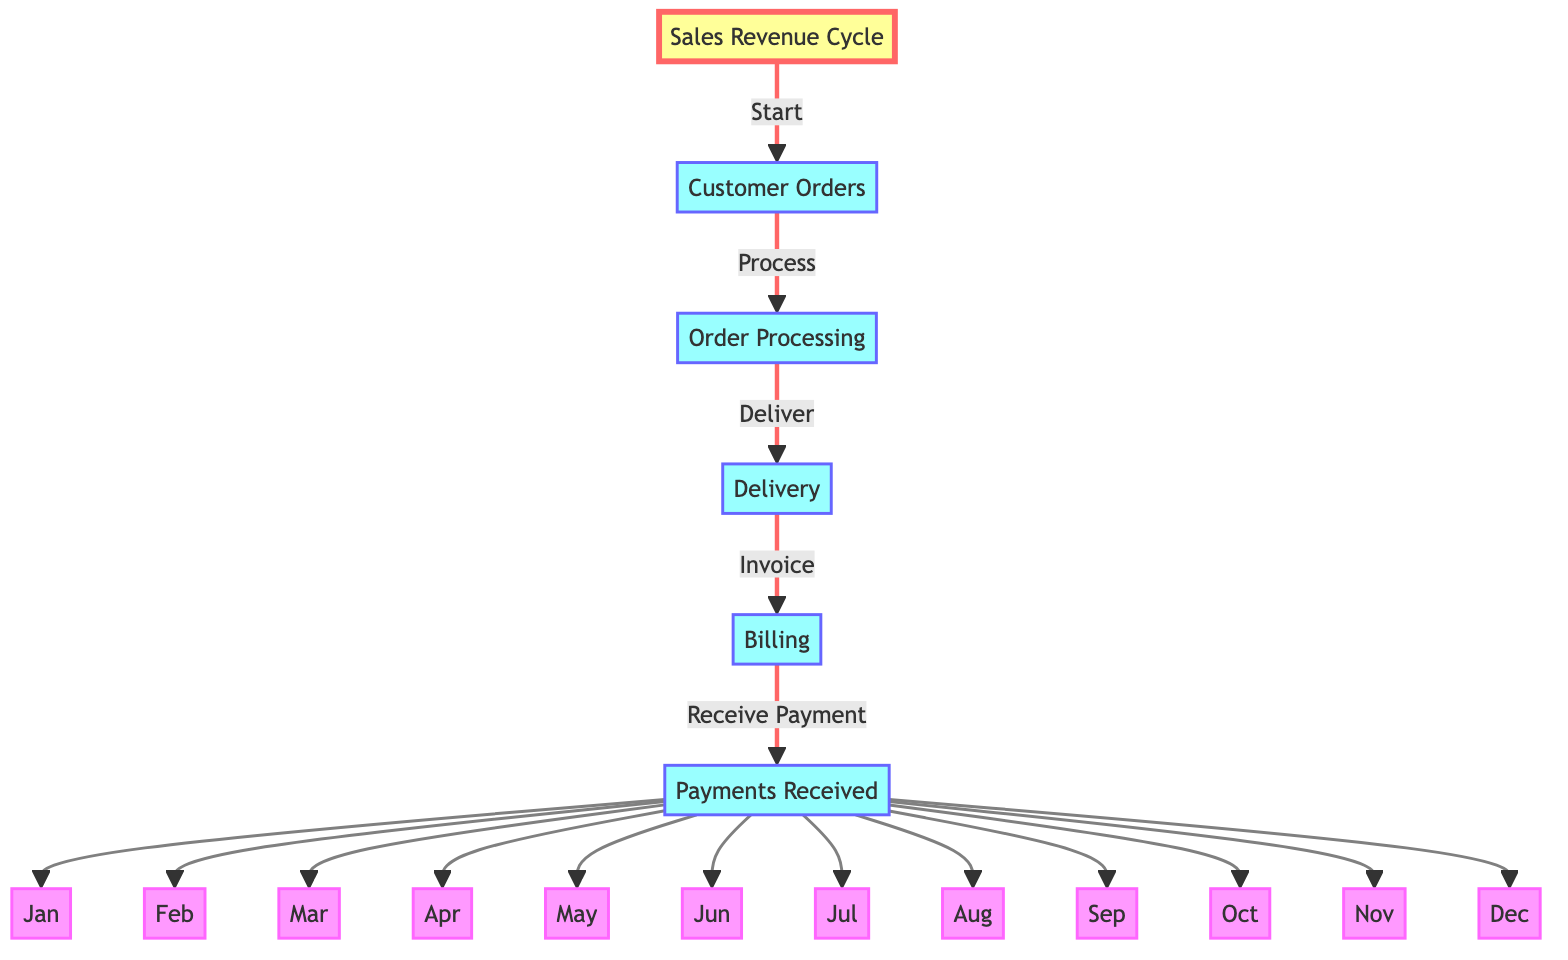What is the first step in the Sales Revenue Cycle? In the diagram, the first step is represented by the node that leads out from "Sales Revenue Cycle," which is "Customer Orders."
Answer: Customer Orders How many stages are there in the Sales Revenue Cycle? By counting the nodes associated with the main cycle excluding months, there are five key stages: "Customer Orders," "Order Processing," "Delivery," "Billing," and "Payments Received."
Answer: Five Which month follows June in the diagram? According to the flow from month nodes, the sequence of months goes from June directly to July.
Answer: July What process happens after Order Processing? Following the "Order Processing" node, the next step indicated in the flow is "Delivery."
Answer: Delivery Which two nodes are directly connected? Examining the flow from "Payments Received," it is connected directly to all month nodes, meaning it connects to "Jan," "Feb," all the way through "Dec."
Answer: All months How many process steps are there before billing? The steps before "Billing" include "Customer Orders," "Order Processing," and "Delivery," which totals to three steps.
Answer: Three If a customer places an order in April, when do they make their payment? In the cycle, after all steps, payments are received in the months represented in sequence following billing; hence, if they order in April, their payment is recorded in April or later months.
Answer: April What relationship exists between Billing and Payments Received? The flow indicates that "Billing" directly leads to "Payments Received," meaning billing must occur before payments can be received.
Answer: Direct relationship What color represents the monthly nodes in the diagram? The color used for the month nodes is pink, as indicated by the class definition applied to those nodes.
Answer: Pink 